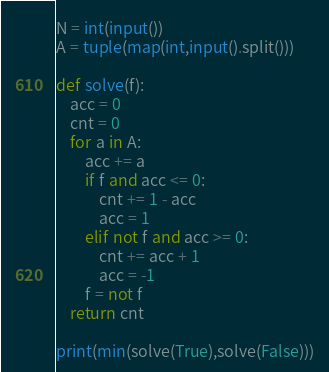<code> <loc_0><loc_0><loc_500><loc_500><_Python_>N = int(input())
A = tuple(map(int,input().split()))

def solve(f):
    acc = 0
    cnt = 0
    for a in A:
        acc += a
        if f and acc <= 0:
            cnt += 1 - acc
            acc = 1
        elif not f and acc >= 0:
            cnt += acc + 1
            acc = -1
        f = not f
    return cnt

print(min(solve(True),solve(False)))</code> 